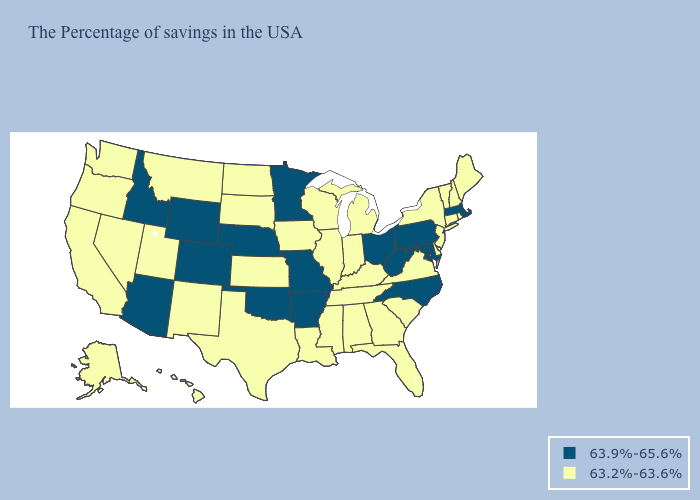What is the lowest value in the USA?
Concise answer only. 63.2%-63.6%. What is the highest value in states that border Nebraska?
Be succinct. 63.9%-65.6%. What is the value of New Hampshire?
Keep it brief. 63.2%-63.6%. Name the states that have a value in the range 63.9%-65.6%?
Give a very brief answer. Massachusetts, Maryland, Pennsylvania, North Carolina, West Virginia, Ohio, Missouri, Arkansas, Minnesota, Nebraska, Oklahoma, Wyoming, Colorado, Arizona, Idaho. Name the states that have a value in the range 63.2%-63.6%?
Concise answer only. Maine, Rhode Island, New Hampshire, Vermont, Connecticut, New York, New Jersey, Delaware, Virginia, South Carolina, Florida, Georgia, Michigan, Kentucky, Indiana, Alabama, Tennessee, Wisconsin, Illinois, Mississippi, Louisiana, Iowa, Kansas, Texas, South Dakota, North Dakota, New Mexico, Utah, Montana, Nevada, California, Washington, Oregon, Alaska, Hawaii. What is the highest value in states that border North Carolina?
Give a very brief answer. 63.2%-63.6%. How many symbols are there in the legend?
Be succinct. 2. Which states hav the highest value in the Northeast?
Write a very short answer. Massachusetts, Pennsylvania. Does Missouri have the highest value in the MidWest?
Write a very short answer. Yes. Which states have the highest value in the USA?
Short answer required. Massachusetts, Maryland, Pennsylvania, North Carolina, West Virginia, Ohio, Missouri, Arkansas, Minnesota, Nebraska, Oklahoma, Wyoming, Colorado, Arizona, Idaho. What is the value of North Dakota?
Write a very short answer. 63.2%-63.6%. What is the highest value in the MidWest ?
Concise answer only. 63.9%-65.6%. Does Hawaii have a higher value than Louisiana?
Write a very short answer. No. Is the legend a continuous bar?
Give a very brief answer. No. Name the states that have a value in the range 63.9%-65.6%?
Give a very brief answer. Massachusetts, Maryland, Pennsylvania, North Carolina, West Virginia, Ohio, Missouri, Arkansas, Minnesota, Nebraska, Oklahoma, Wyoming, Colorado, Arizona, Idaho. 